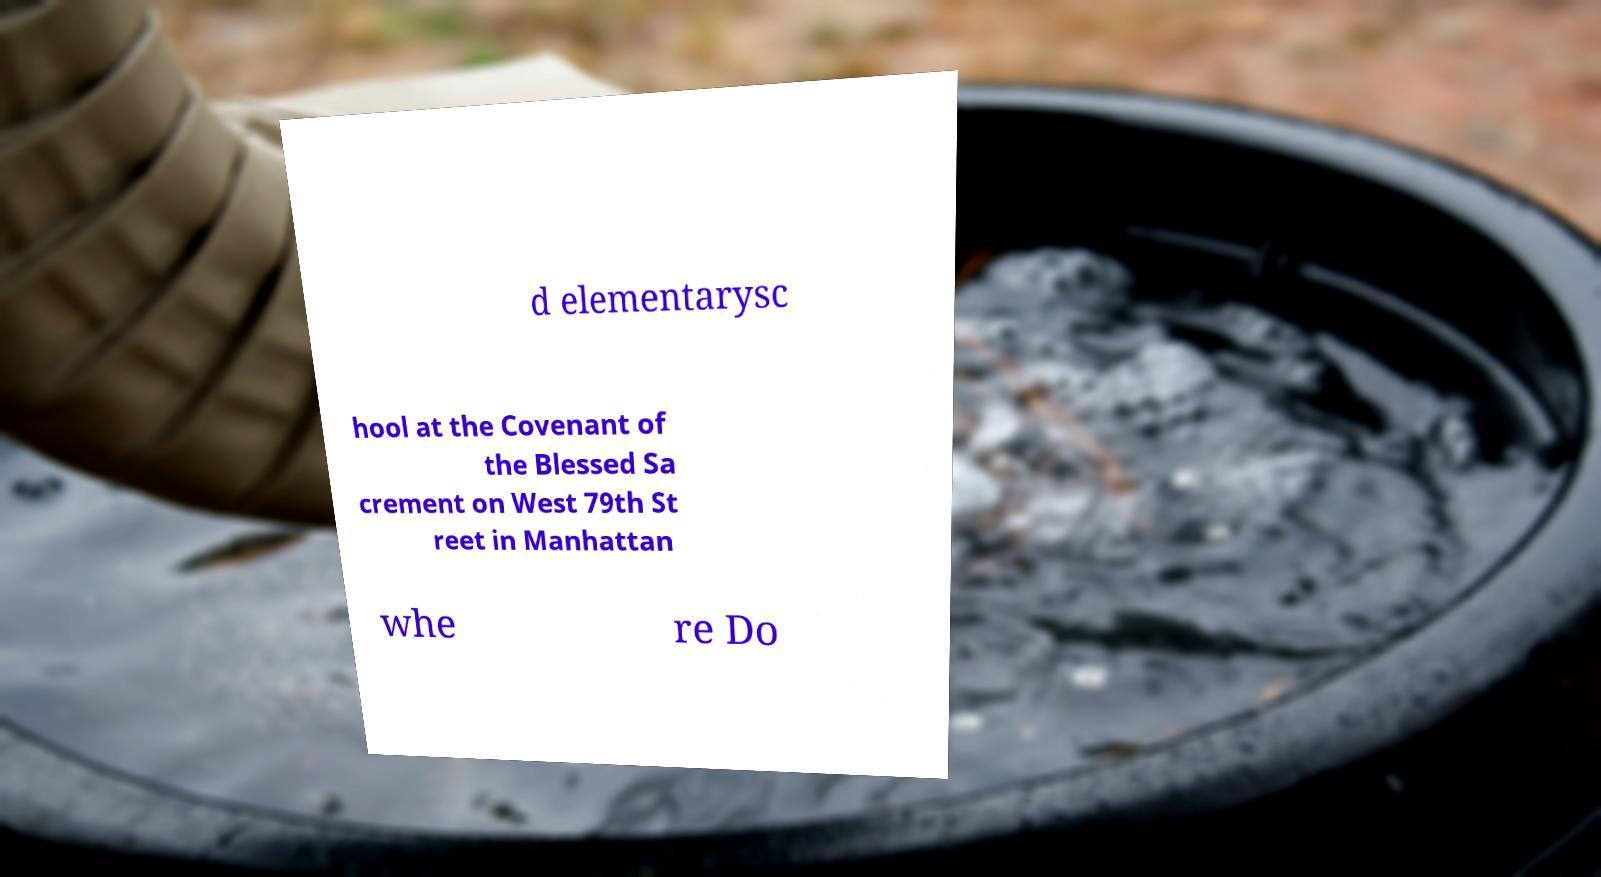Could you extract and type out the text from this image? d elementarysc hool at the Covenant of the Blessed Sa crement on West 79th St reet in Manhattan whe re Do 